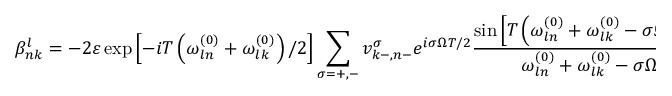Convert formula to latex. <formula><loc_0><loc_0><loc_500><loc_500>\beta _ { n k } ^ { l } = - 2 \varepsilon \exp \left [ - i T \left ( \omega _ { \ln } ^ { ( 0 ) } + \omega _ { l k } ^ { ( 0 ) } \right ) / 2 \right ] \sum _ { \sigma = + , - } v _ { k - , n - } ^ { \sigma } e ^ { i \sigma \Omega T / 2 } \frac { \sin \left [ T \left ( \omega _ { \ln } ^ { ( 0 ) } + \omega _ { l k } ^ { ( 0 ) } - \sigma \Omega \right ) / 2 \right ] } { \omega _ { \ln } ^ { ( 0 ) } + \omega _ { l k } ^ { ( 0 ) } - \sigma \Omega }</formula> 